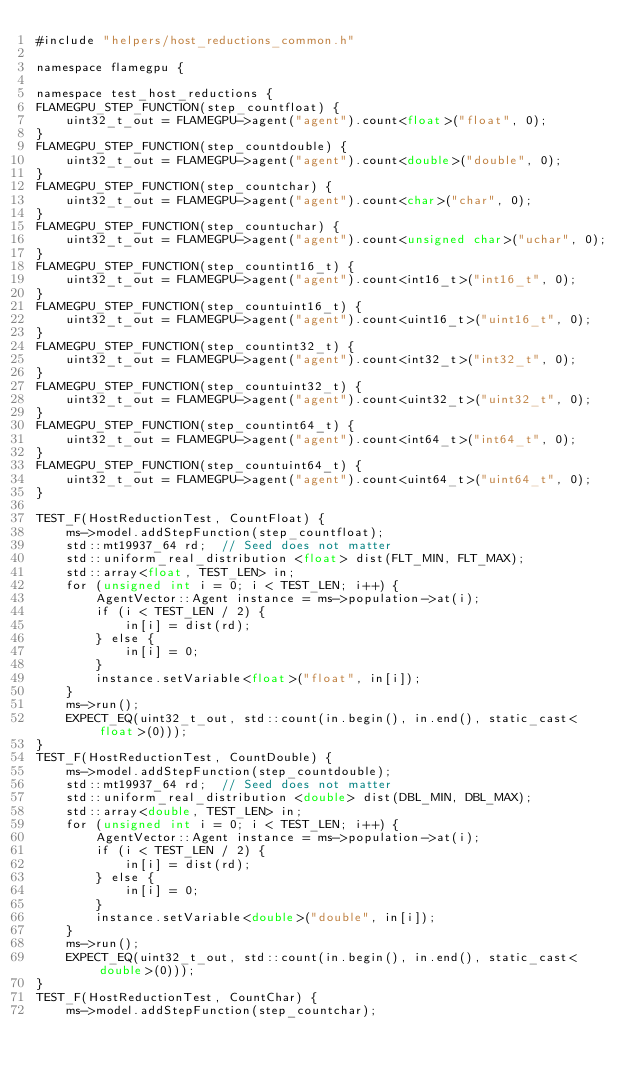Convert code to text. <code><loc_0><loc_0><loc_500><loc_500><_Cuda_>#include "helpers/host_reductions_common.h"

namespace flamegpu {

namespace test_host_reductions {
FLAMEGPU_STEP_FUNCTION(step_countfloat) {
    uint32_t_out = FLAMEGPU->agent("agent").count<float>("float", 0);
}
FLAMEGPU_STEP_FUNCTION(step_countdouble) {
    uint32_t_out = FLAMEGPU->agent("agent").count<double>("double", 0);
}
FLAMEGPU_STEP_FUNCTION(step_countchar) {
    uint32_t_out = FLAMEGPU->agent("agent").count<char>("char", 0);
}
FLAMEGPU_STEP_FUNCTION(step_countuchar) {
    uint32_t_out = FLAMEGPU->agent("agent").count<unsigned char>("uchar", 0);
}
FLAMEGPU_STEP_FUNCTION(step_countint16_t) {
    uint32_t_out = FLAMEGPU->agent("agent").count<int16_t>("int16_t", 0);
}
FLAMEGPU_STEP_FUNCTION(step_countuint16_t) {
    uint32_t_out = FLAMEGPU->agent("agent").count<uint16_t>("uint16_t", 0);
}
FLAMEGPU_STEP_FUNCTION(step_countint32_t) {
    uint32_t_out = FLAMEGPU->agent("agent").count<int32_t>("int32_t", 0);
}
FLAMEGPU_STEP_FUNCTION(step_countuint32_t) {
    uint32_t_out = FLAMEGPU->agent("agent").count<uint32_t>("uint32_t", 0);
}
FLAMEGPU_STEP_FUNCTION(step_countint64_t) {
    uint32_t_out = FLAMEGPU->agent("agent").count<int64_t>("int64_t", 0);
}
FLAMEGPU_STEP_FUNCTION(step_countuint64_t) {
    uint32_t_out = FLAMEGPU->agent("agent").count<uint64_t>("uint64_t", 0);
}

TEST_F(HostReductionTest, CountFloat) {
    ms->model.addStepFunction(step_countfloat);
    std::mt19937_64 rd;  // Seed does not matter
    std::uniform_real_distribution <float> dist(FLT_MIN, FLT_MAX);
    std::array<float, TEST_LEN> in;
    for (unsigned int i = 0; i < TEST_LEN; i++) {
        AgentVector::Agent instance = ms->population->at(i);
        if (i < TEST_LEN / 2) {
            in[i] = dist(rd);
        } else {
            in[i] = 0;
        }
        instance.setVariable<float>("float", in[i]);
    }
    ms->run();
    EXPECT_EQ(uint32_t_out, std::count(in.begin(), in.end(), static_cast<float>(0)));
}
TEST_F(HostReductionTest, CountDouble) {
    ms->model.addStepFunction(step_countdouble);
    std::mt19937_64 rd;  // Seed does not matter
    std::uniform_real_distribution <double> dist(DBL_MIN, DBL_MAX);
    std::array<double, TEST_LEN> in;
    for (unsigned int i = 0; i < TEST_LEN; i++) {
        AgentVector::Agent instance = ms->population->at(i);
        if (i < TEST_LEN / 2) {
            in[i] = dist(rd);
        } else {
            in[i] = 0;
        }
        instance.setVariable<double>("double", in[i]);
    }
    ms->run();
    EXPECT_EQ(uint32_t_out, std::count(in.begin(), in.end(), static_cast<double>(0)));
}
TEST_F(HostReductionTest, CountChar) {
    ms->model.addStepFunction(step_countchar);</code> 